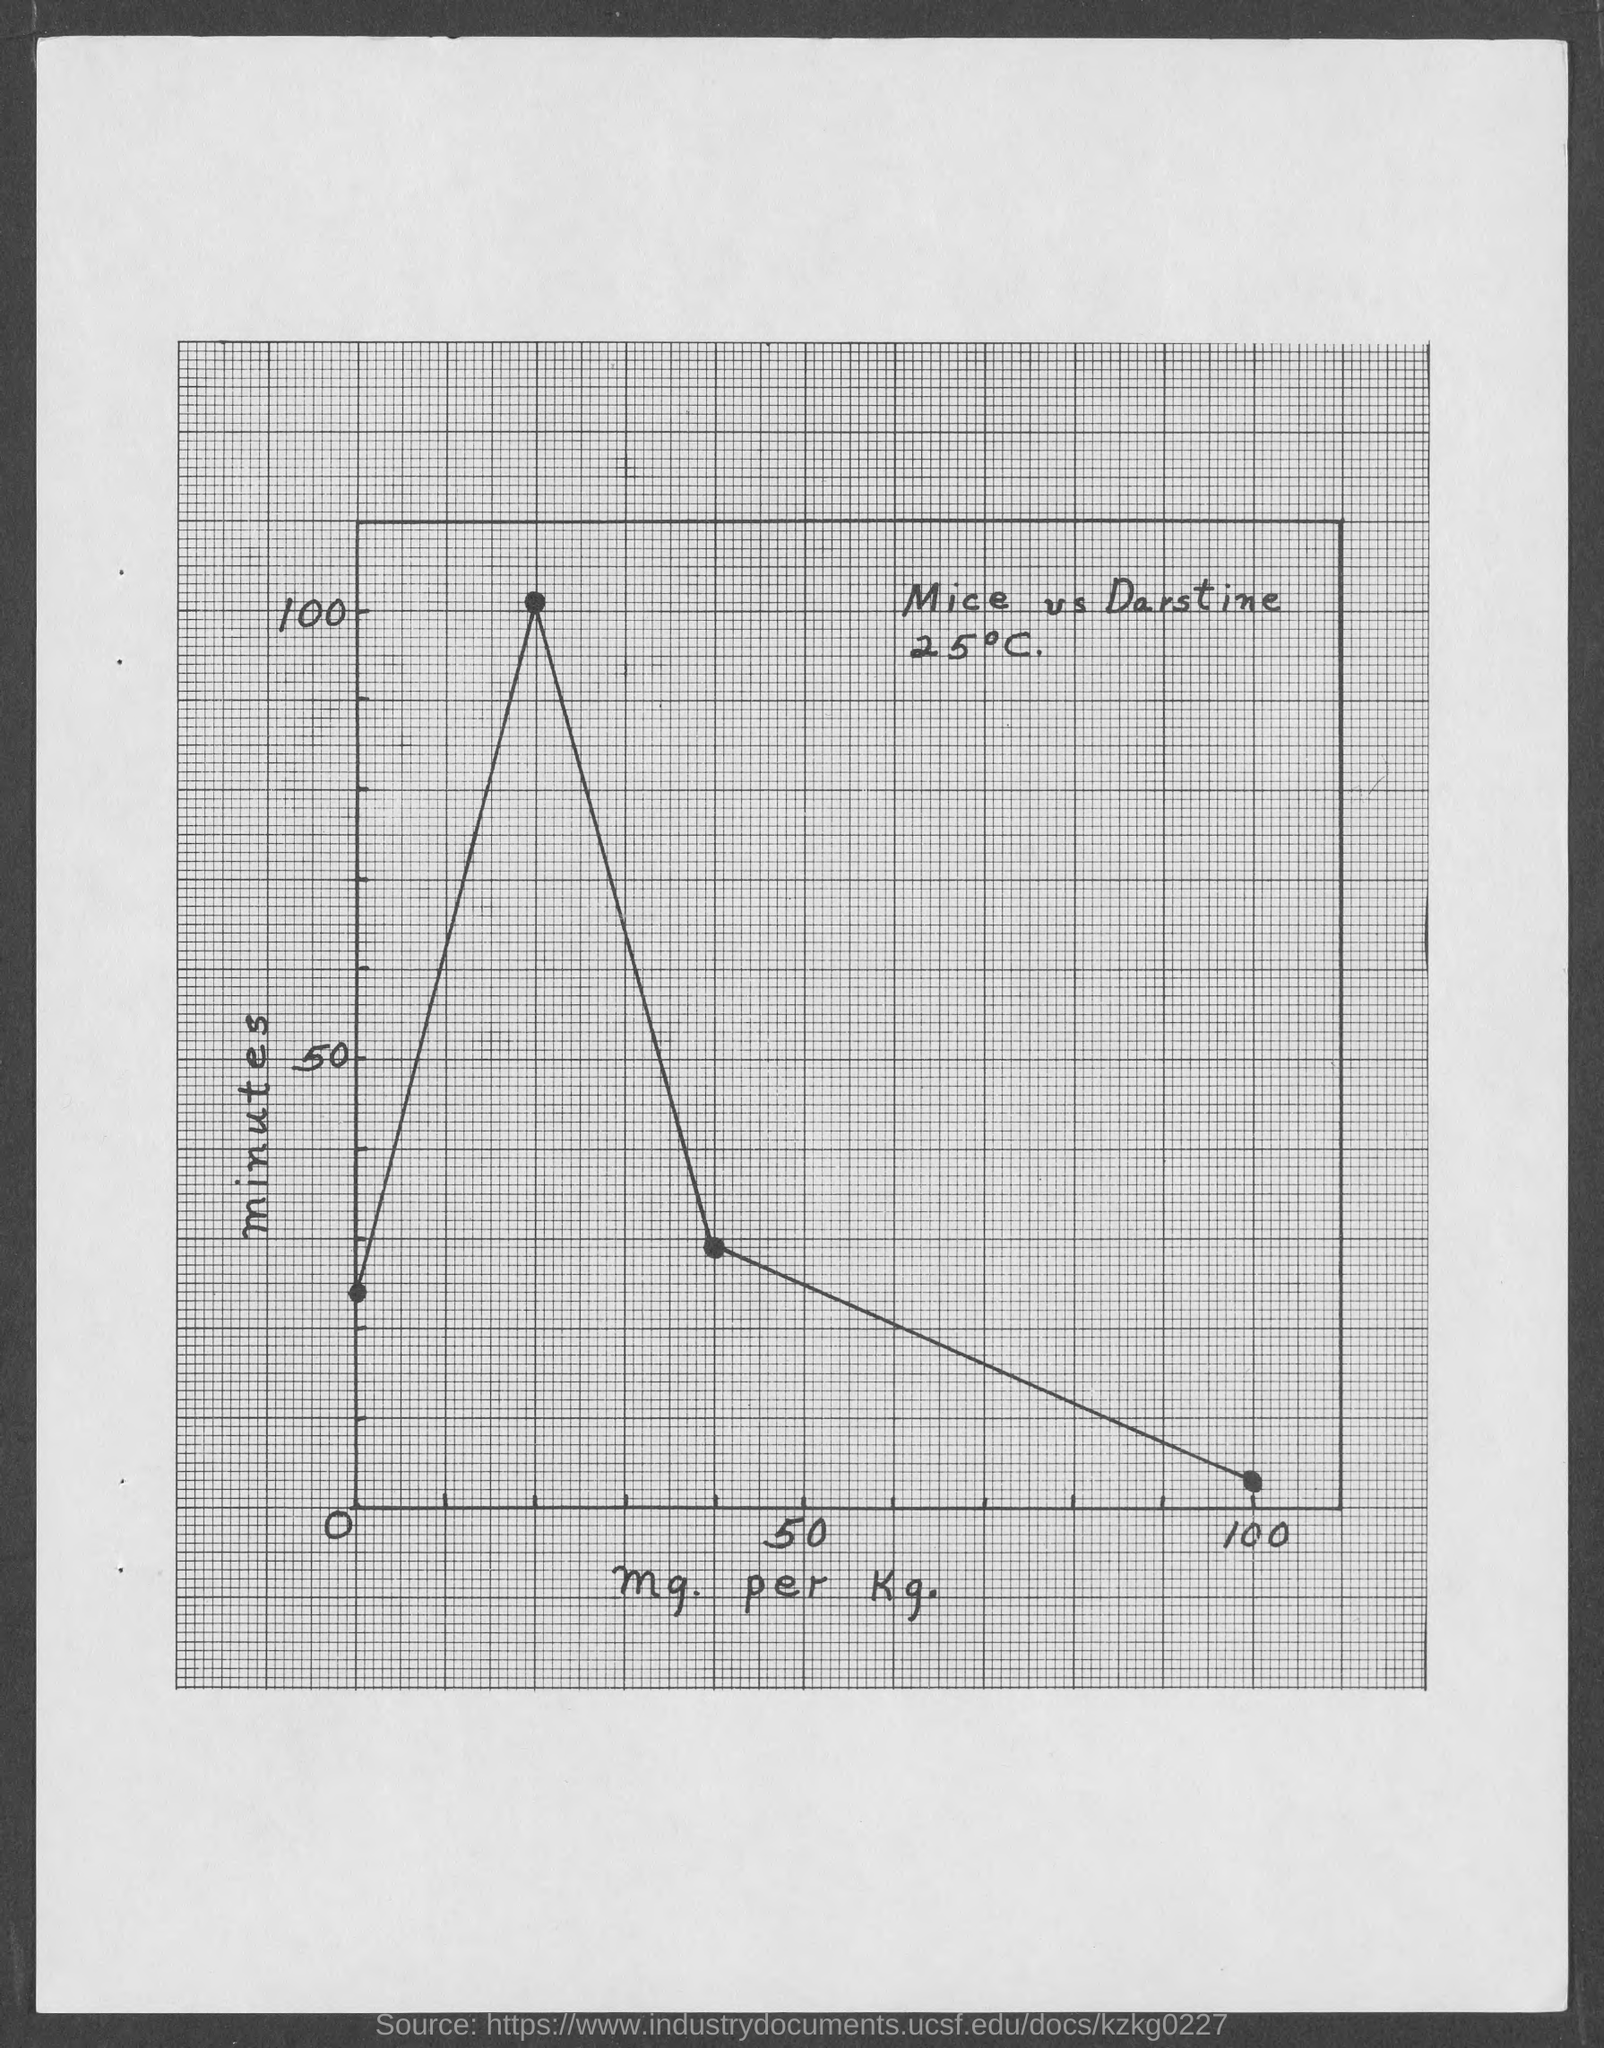What does x-axis of the graph represent?
Give a very brief answer. Mg. per kg. What does y-axis of the graph represent?
Give a very brief answer. Minutes. 